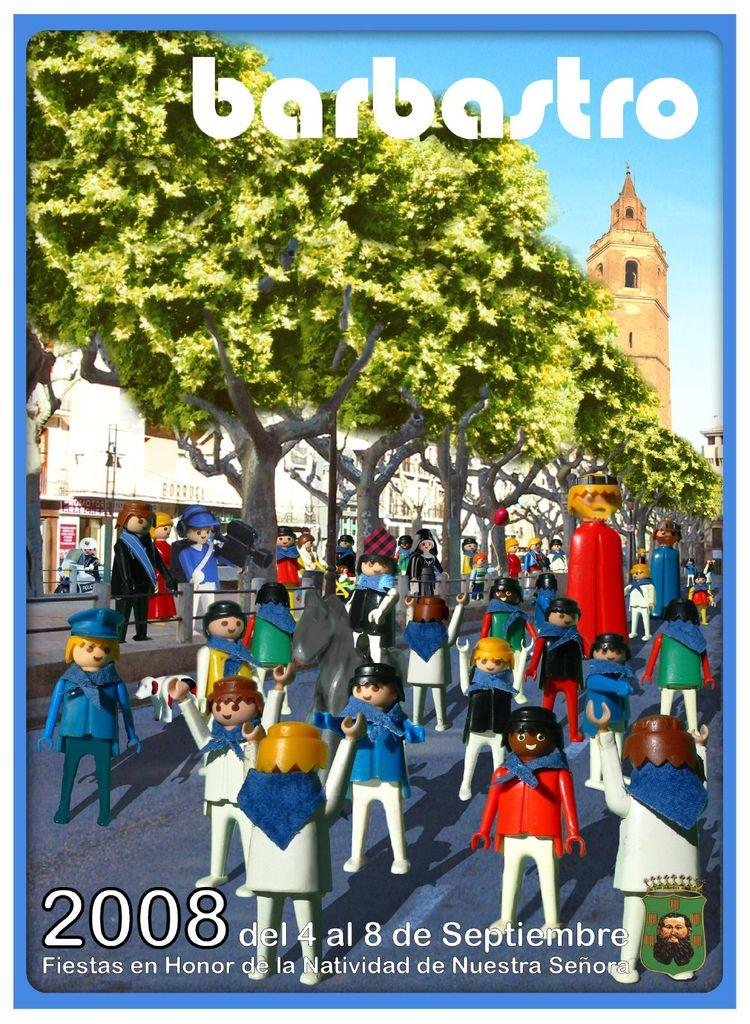<image>
Present a compact description of the photo's key features. cover of the magazine barbastro with several toy men walking down a street. 